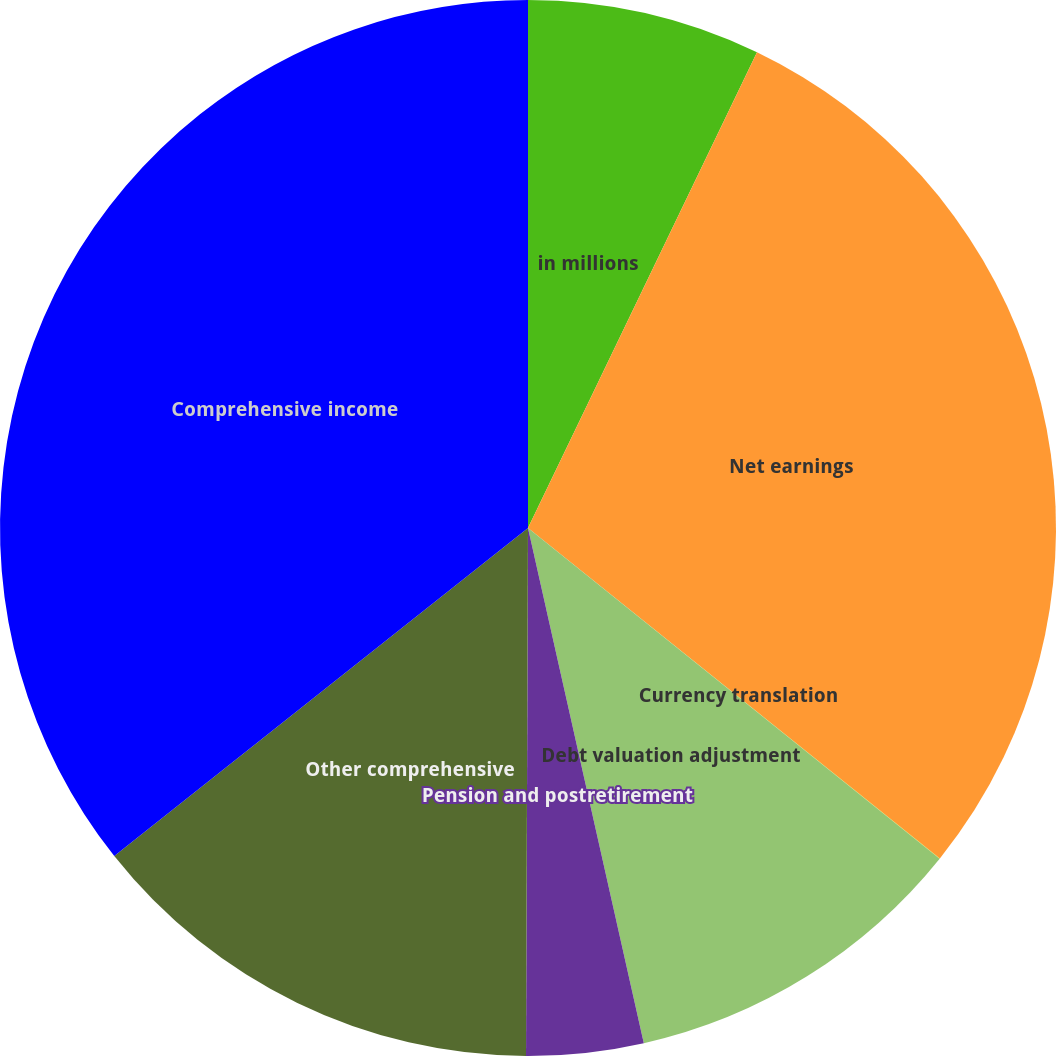Convert chart. <chart><loc_0><loc_0><loc_500><loc_500><pie_chart><fcel>in millions<fcel>Net earnings<fcel>Currency translation<fcel>Debt valuation adjustment<fcel>Pension and postretirement<fcel>Other comprehensive<fcel>Comprehensive income<nl><fcel>7.14%<fcel>28.62%<fcel>0.01%<fcel>10.71%<fcel>3.58%<fcel>14.27%<fcel>35.67%<nl></chart> 